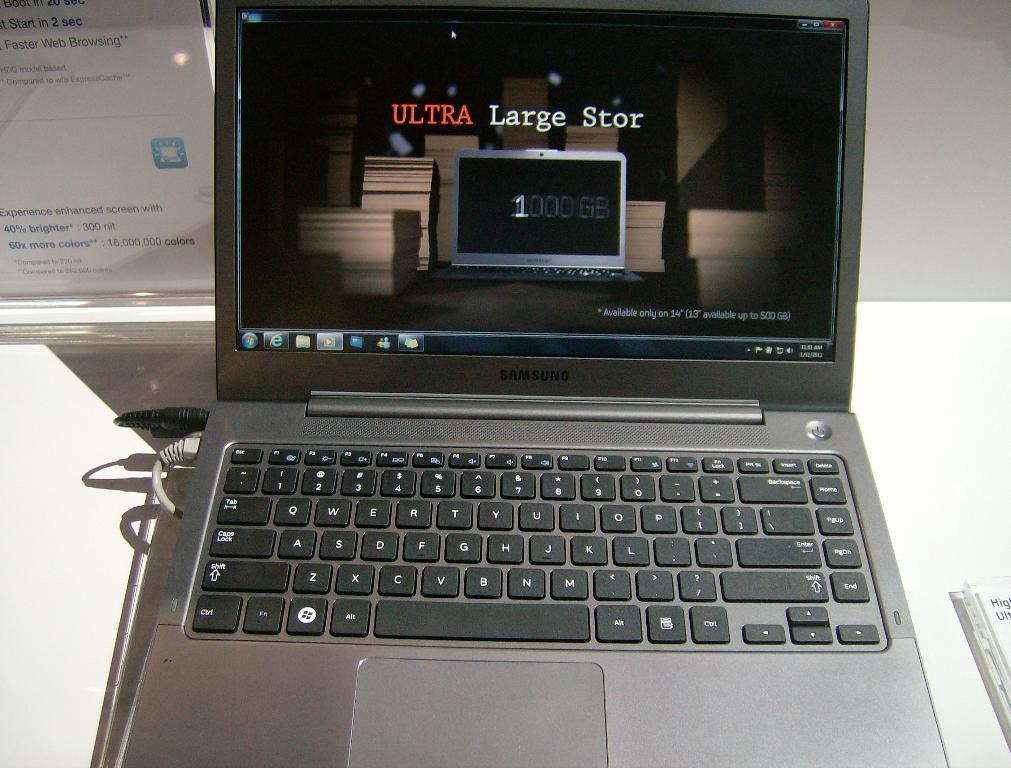<image>
Create a compact narrative representing the image presented. A Samsung laptop sits open on a white surface. 